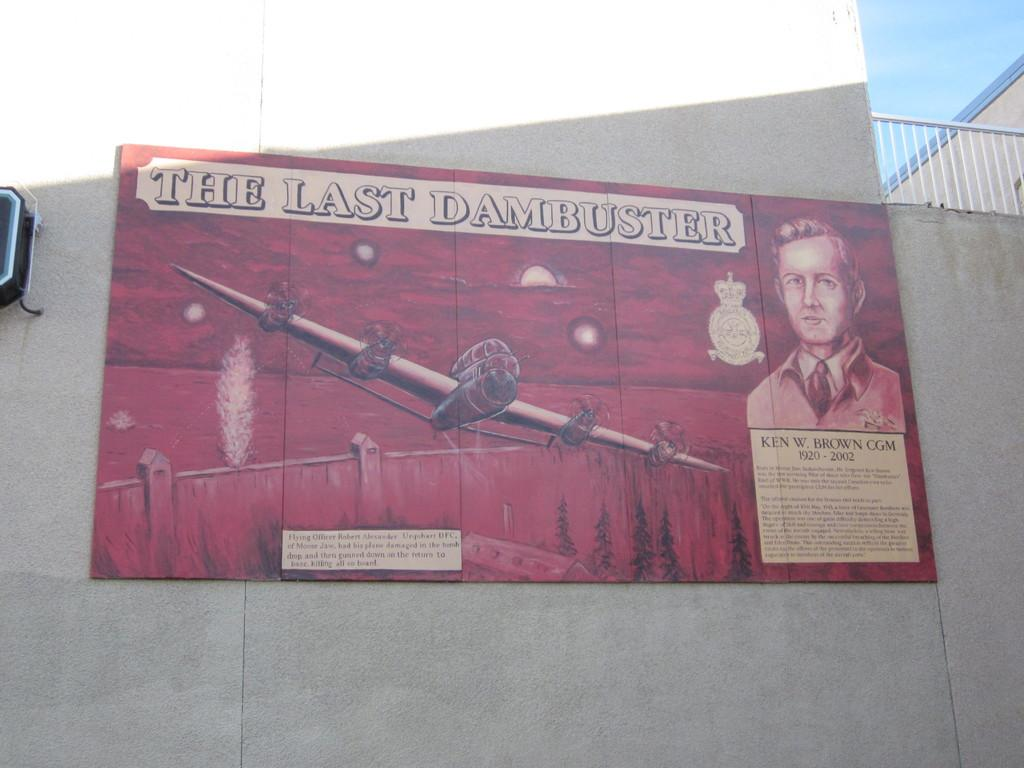Provide a one-sentence caption for the provided image. A red billboard showing a WW2 fighter plane going over a dam with the words "The Last Dambuster" written at the top. 